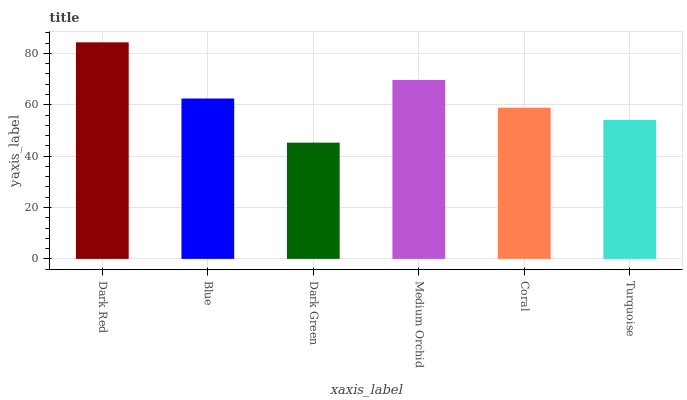Is Dark Green the minimum?
Answer yes or no. Yes. Is Dark Red the maximum?
Answer yes or no. Yes. Is Blue the minimum?
Answer yes or no. No. Is Blue the maximum?
Answer yes or no. No. Is Dark Red greater than Blue?
Answer yes or no. Yes. Is Blue less than Dark Red?
Answer yes or no. Yes. Is Blue greater than Dark Red?
Answer yes or no. No. Is Dark Red less than Blue?
Answer yes or no. No. Is Blue the high median?
Answer yes or no. Yes. Is Coral the low median?
Answer yes or no. Yes. Is Medium Orchid the high median?
Answer yes or no. No. Is Medium Orchid the low median?
Answer yes or no. No. 